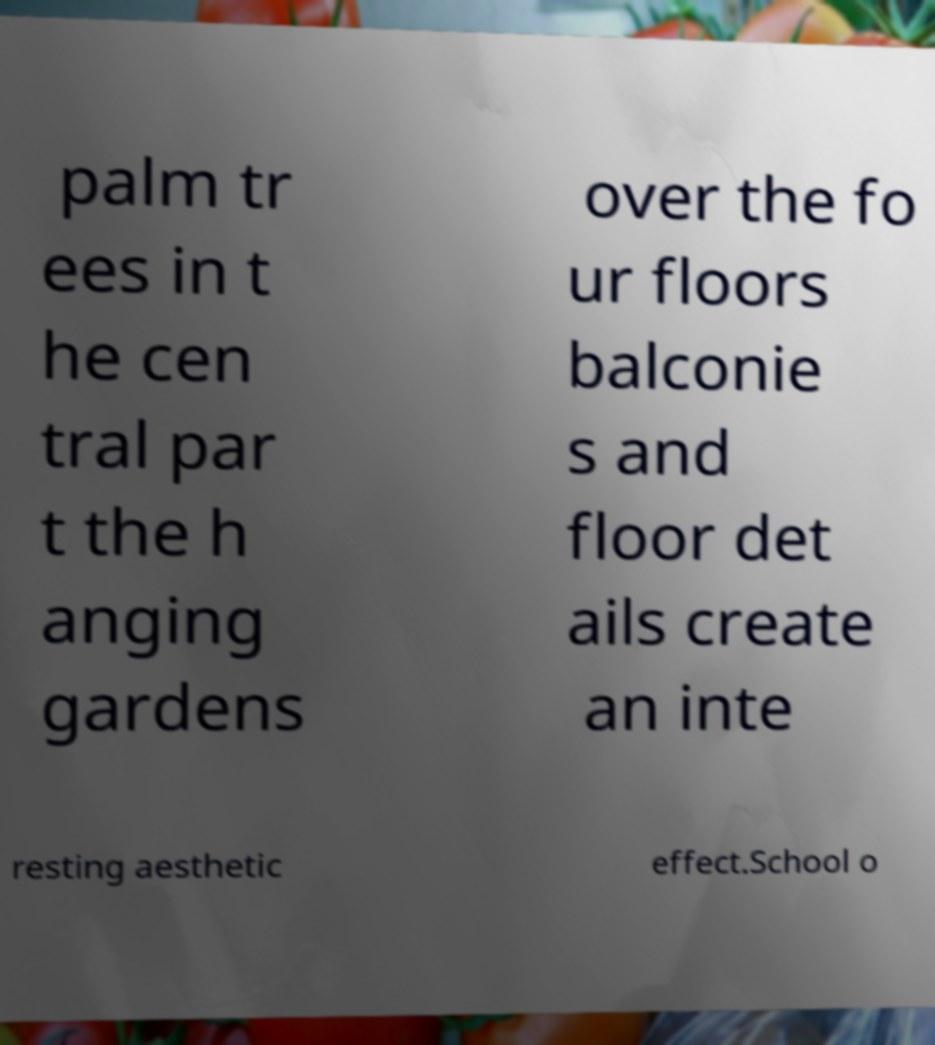There's text embedded in this image that I need extracted. Can you transcribe it verbatim? palm tr ees in t he cen tral par t the h anging gardens over the fo ur floors balconie s and floor det ails create an inte resting aesthetic effect.School o 